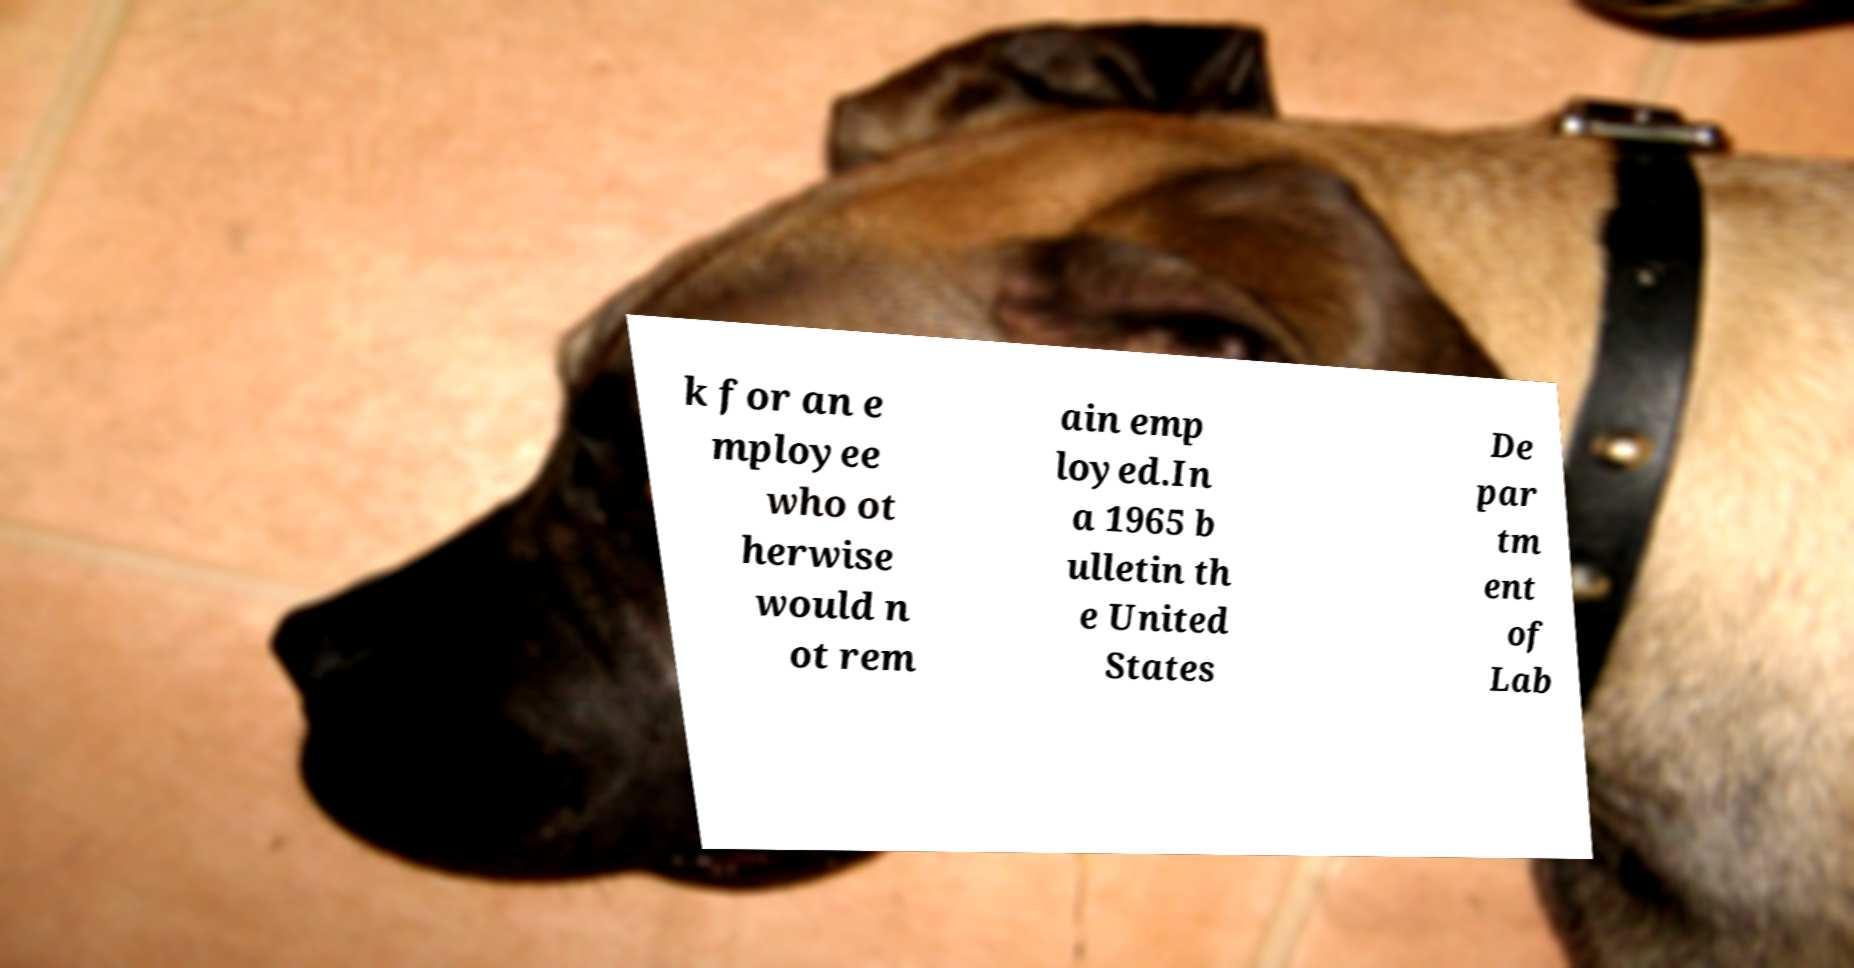Please read and relay the text visible in this image. What does it say? k for an e mployee who ot herwise would n ot rem ain emp loyed.In a 1965 b ulletin th e United States De par tm ent of Lab 